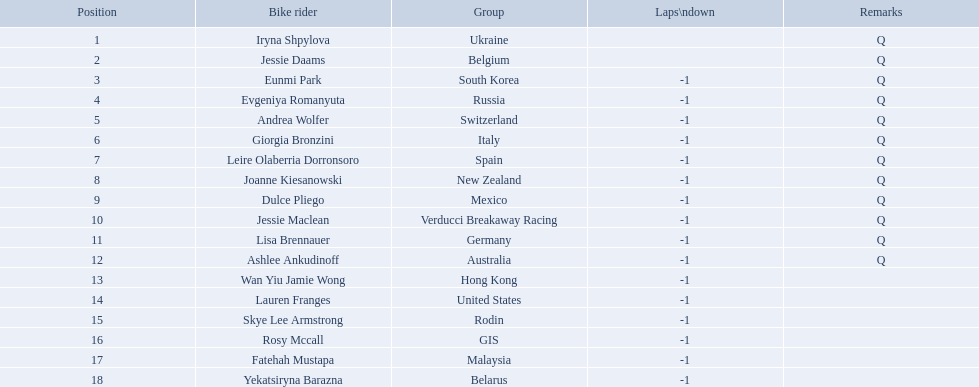Who are all of the cyclists in this race? Iryna Shpylova, Jessie Daams, Eunmi Park, Evgeniya Romanyuta, Andrea Wolfer, Giorgia Bronzini, Leire Olaberria Dorronsoro, Joanne Kiesanowski, Dulce Pliego, Jessie Maclean, Lisa Brennauer, Ashlee Ankudinoff, Wan Yiu Jamie Wong, Lauren Franges, Skye Lee Armstrong, Rosy Mccall, Fatehah Mustapa, Yekatsiryna Barazna. Of these, which one has the lowest numbered rank? Iryna Shpylova. 